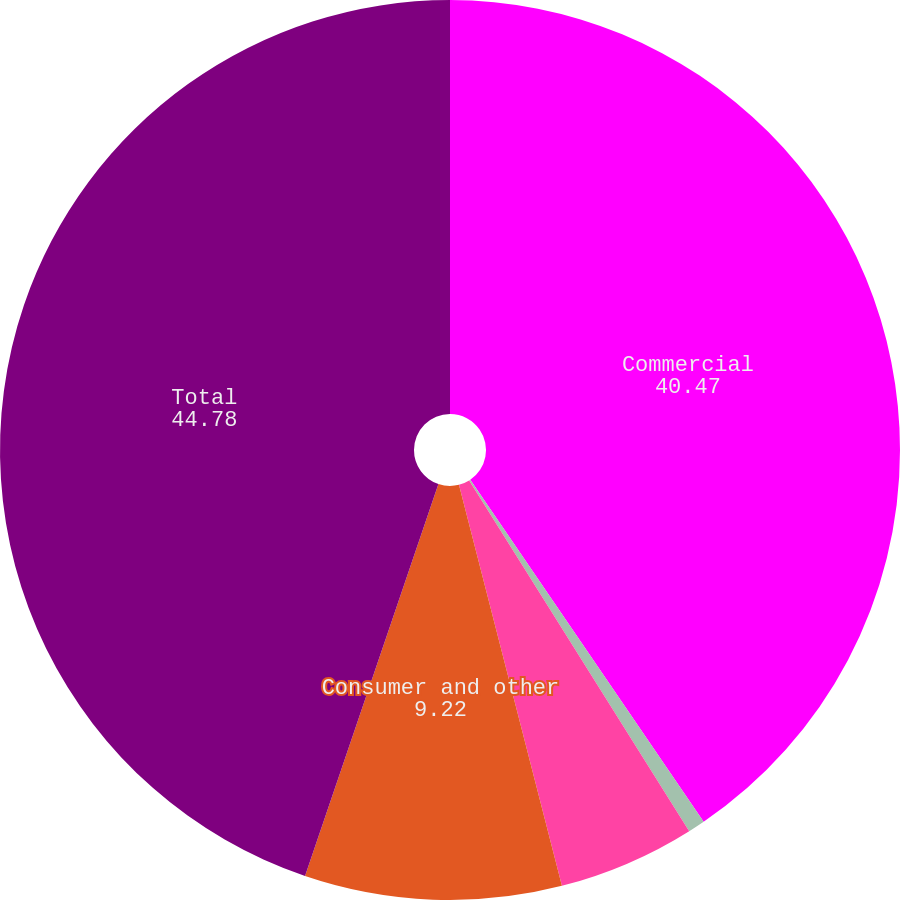Convert chart. <chart><loc_0><loc_0><loc_500><loc_500><pie_chart><fcel>Commercial<fcel>Real estate term<fcel>Real estate construction<fcel>Consumer and other<fcel>Total<nl><fcel>40.47%<fcel>0.61%<fcel>4.92%<fcel>9.22%<fcel>44.78%<nl></chart> 